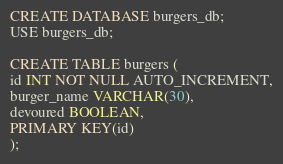Convert code to text. <code><loc_0><loc_0><loc_500><loc_500><_SQL_>CREATE DATABASE burgers_db; 
USE burgers_db;

CREATE TABLE burgers (
id INT NOT NULL AUTO_INCREMENT,
burger_name VARCHAR(30),
devoured BOOLEAN,
PRIMARY KEY(id)
);</code> 